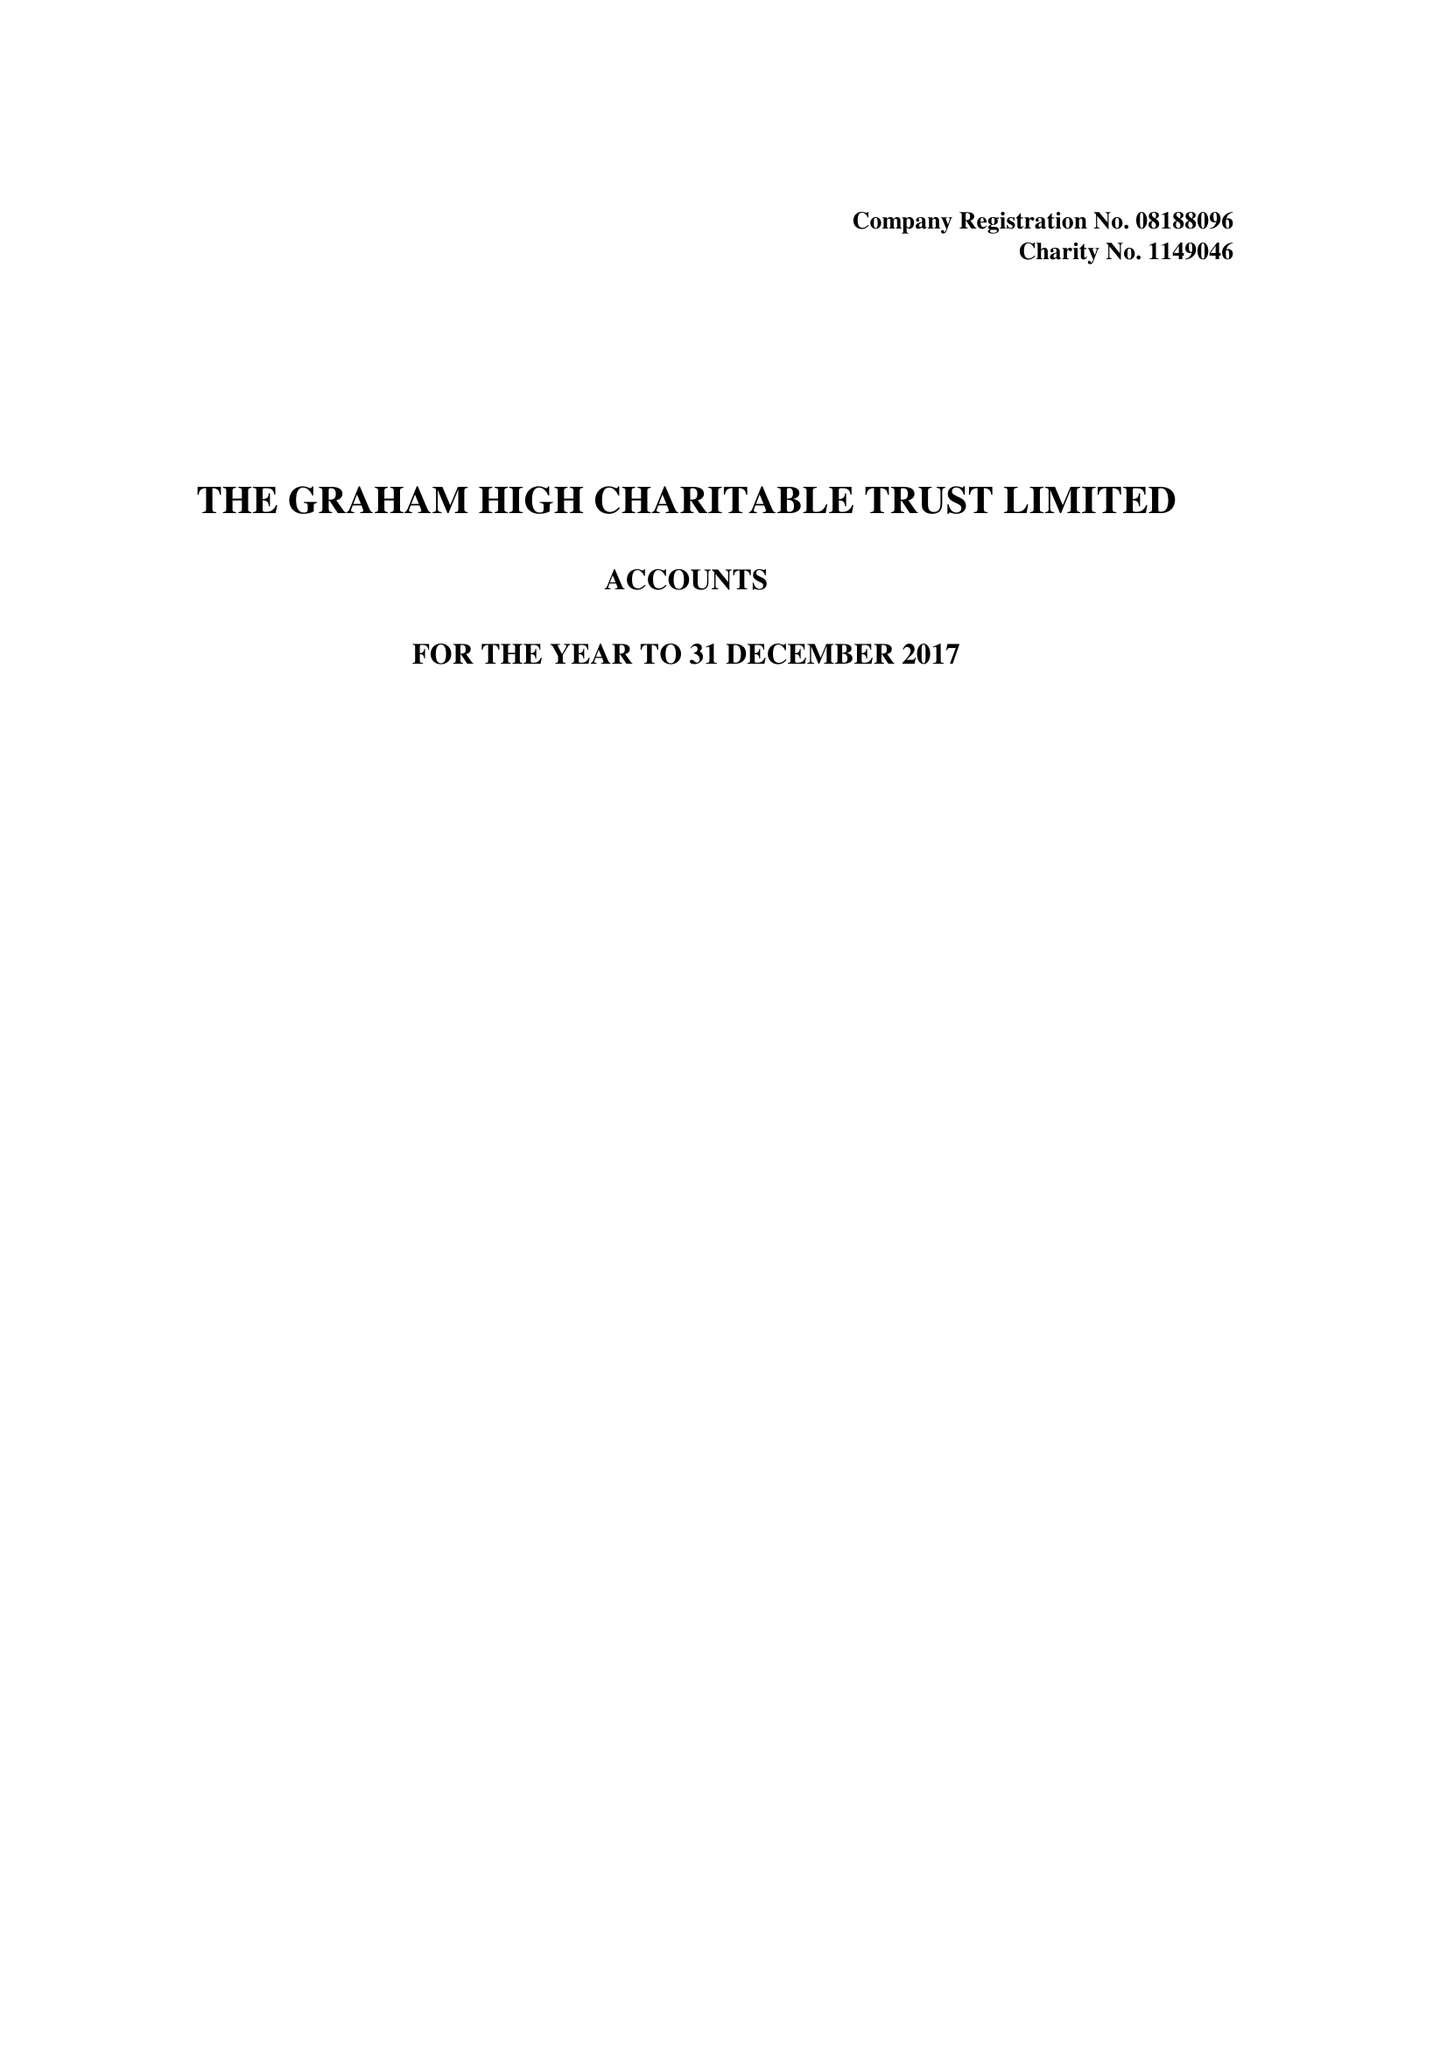What is the value for the address__postcode?
Answer the question using a single word or phrase. SO53 3TL 